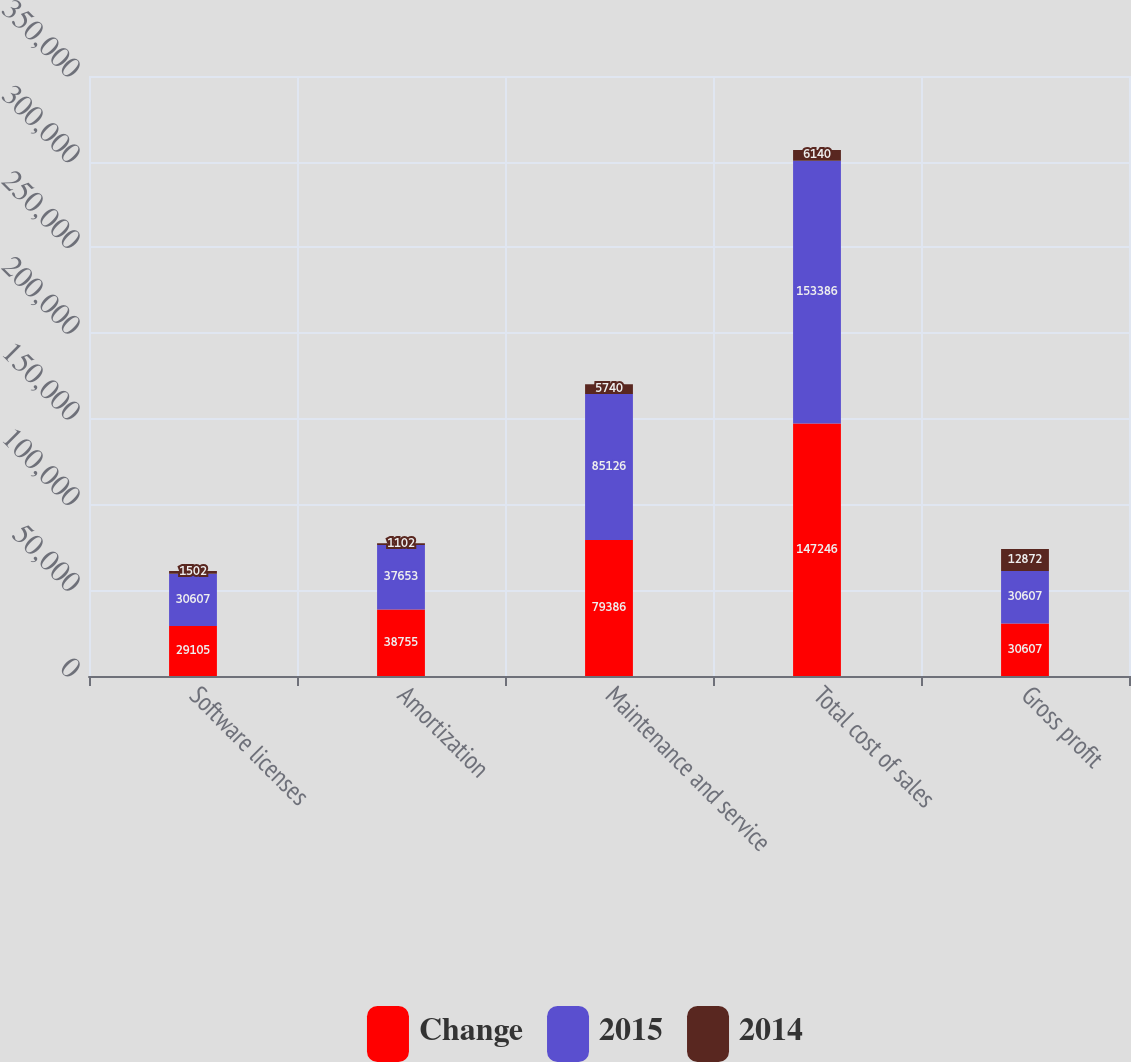<chart> <loc_0><loc_0><loc_500><loc_500><stacked_bar_chart><ecel><fcel>Software licenses<fcel>Amortization<fcel>Maintenance and service<fcel>Total cost of sales<fcel>Gross profit<nl><fcel>Change<fcel>29105<fcel>38755<fcel>79386<fcel>147246<fcel>30607<nl><fcel>2015<fcel>30607<fcel>37653<fcel>85126<fcel>153386<fcel>30607<nl><fcel>2014<fcel>1502<fcel>1102<fcel>5740<fcel>6140<fcel>12872<nl></chart> 